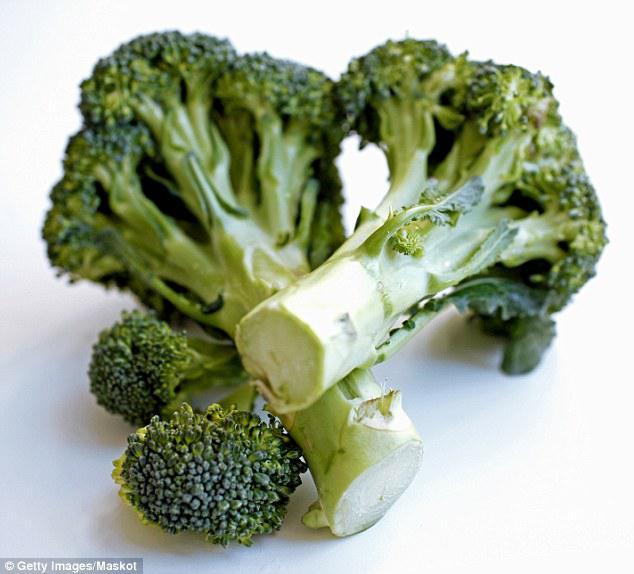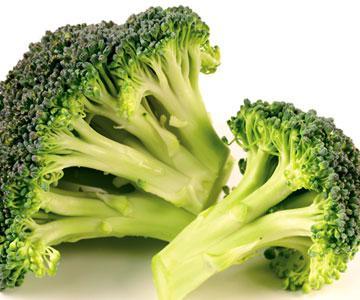The first image is the image on the left, the second image is the image on the right. Considering the images on both sides, is "One image shows broccoli florets in a collander shaped like a dish." valid? Answer yes or no. No. The first image is the image on the left, the second image is the image on the right. For the images shown, is this caption "In 1 of the images, there is broccoli on a plate." true? Answer yes or no. No. 